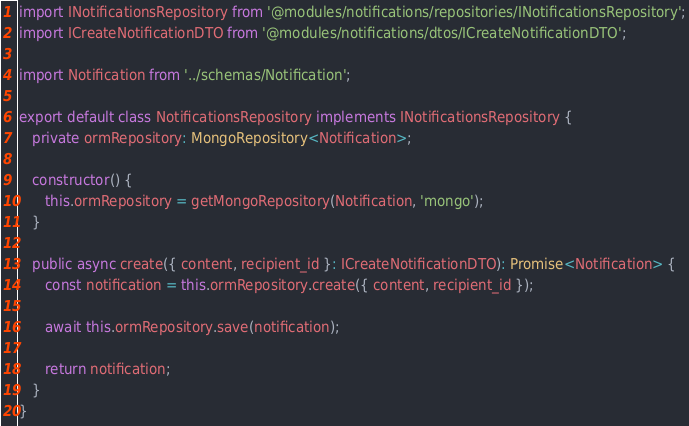<code> <loc_0><loc_0><loc_500><loc_500><_TypeScript_>import INotificationsRepository from '@modules/notifications/repositories/INotificationsRepository';
import ICreateNotificationDTO from '@modules/notifications/dtos/ICreateNotificationDTO';

import Notification from '../schemas/Notification';

export default class NotificationsRepository implements INotificationsRepository {
   private ormRepository: MongoRepository<Notification>;

   constructor() {
      this.ormRepository = getMongoRepository(Notification, 'mongo');
   }

   public async create({ content, recipient_id }: ICreateNotificationDTO): Promise<Notification> {
      const notification = this.ormRepository.create({ content, recipient_id });

      await this.ormRepository.save(notification);

      return notification;
   }
}
</code> 